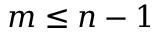Convert formula to latex. <formula><loc_0><loc_0><loc_500><loc_500>m \leq n - 1</formula> 